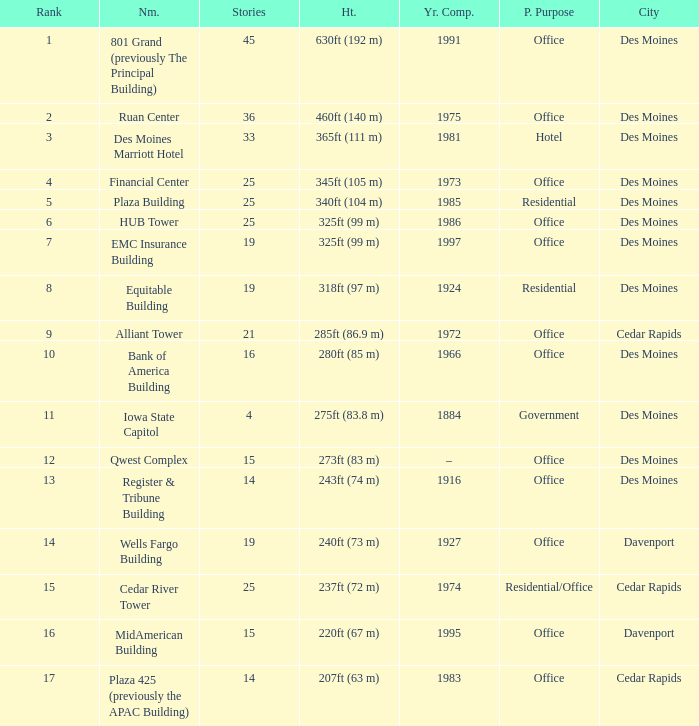What is the measurement of the emc insurance building's height in des moines? 325ft (99 m). 